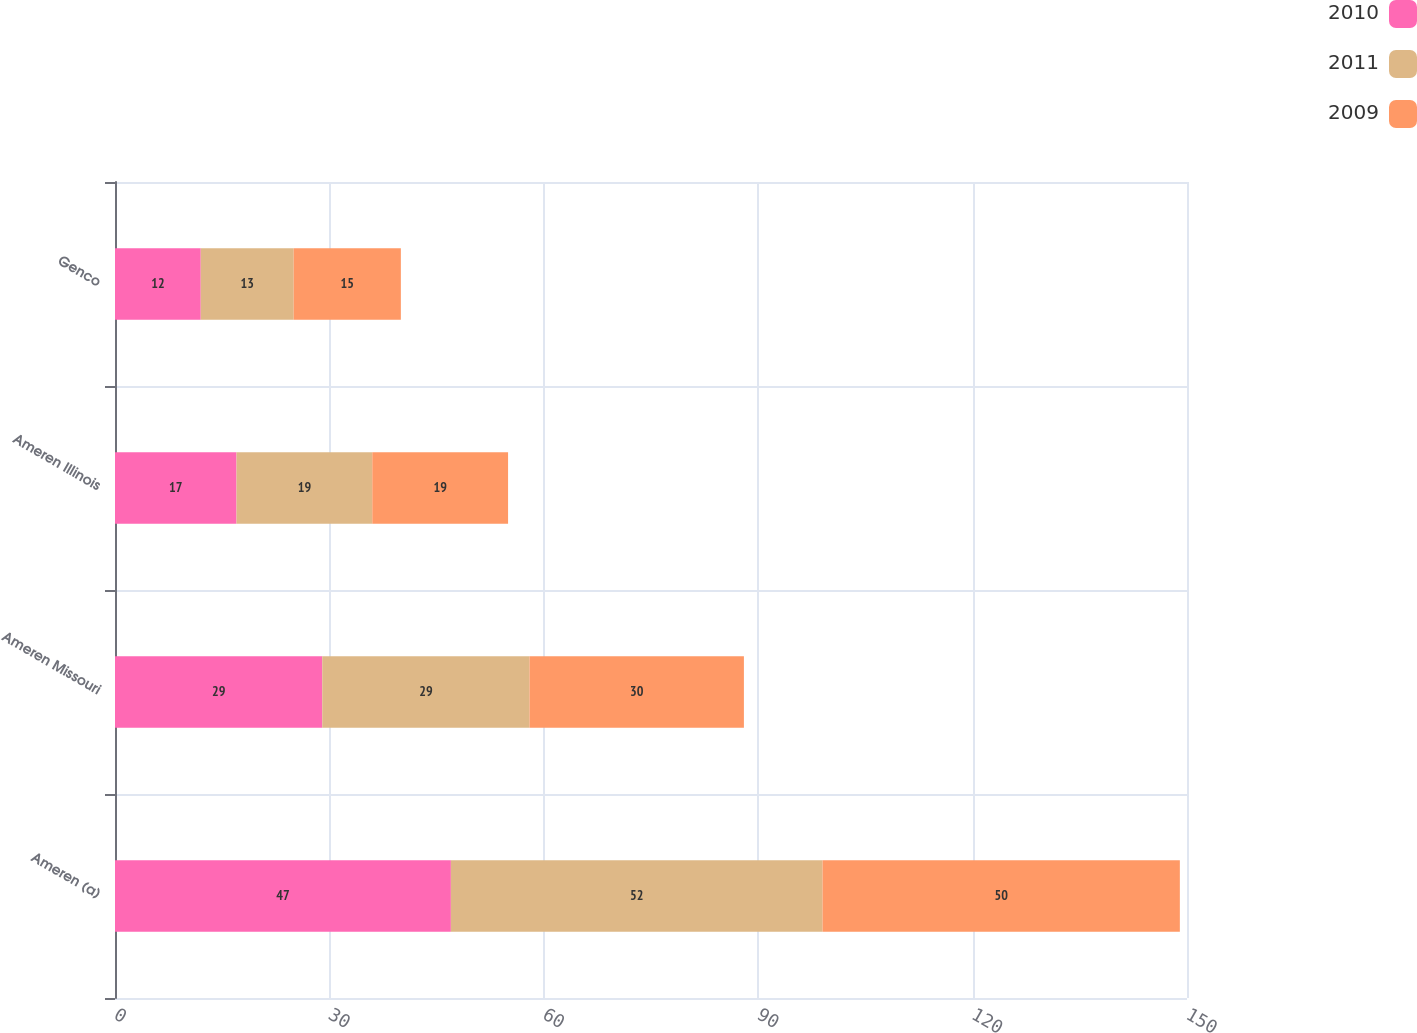<chart> <loc_0><loc_0><loc_500><loc_500><stacked_bar_chart><ecel><fcel>Ameren (a)<fcel>Ameren Missouri<fcel>Ameren Illinois<fcel>Genco<nl><fcel>2010<fcel>47<fcel>29<fcel>17<fcel>12<nl><fcel>2011<fcel>52<fcel>29<fcel>19<fcel>13<nl><fcel>2009<fcel>50<fcel>30<fcel>19<fcel>15<nl></chart> 